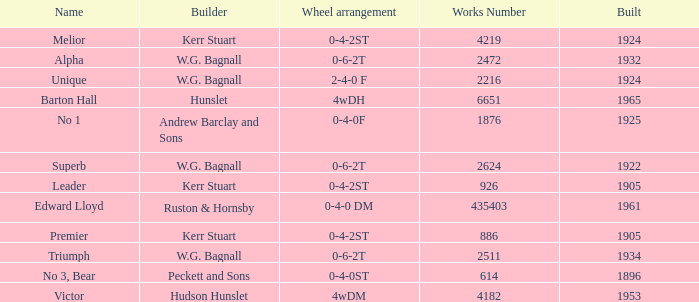Would you mind parsing the complete table? {'header': ['Name', 'Builder', 'Wheel arrangement', 'Works Number', 'Built'], 'rows': [['Melior', 'Kerr Stuart', '0-4-2ST', '4219', '1924'], ['Alpha', 'W.G. Bagnall', '0-6-2T', '2472', '1932'], ['Unique', 'W.G. Bagnall', '2-4-0 F', '2216', '1924'], ['Barton Hall', 'Hunslet', '4wDH', '6651', '1965'], ['No 1', 'Andrew Barclay and Sons', '0-4-0F', '1876', '1925'], ['Superb', 'W.G. Bagnall', '0-6-2T', '2624', '1922'], ['Leader', 'Kerr Stuart', '0-4-2ST', '926', '1905'], ['Edward Lloyd', 'Ruston & Hornsby', '0-4-0 DM', '435403', '1961'], ['Premier', 'Kerr Stuart', '0-4-2ST', '886', '1905'], ['Triumph', 'W.G. Bagnall', '0-6-2T', '2511', '1934'], ['No 3, Bear', 'Peckett and Sons', '0-4-0ST', '614', '1896'], ['Victor', 'Hudson Hunslet', '4wDM', '4182', '1953']]} What is the work number for Victor? 4182.0. 